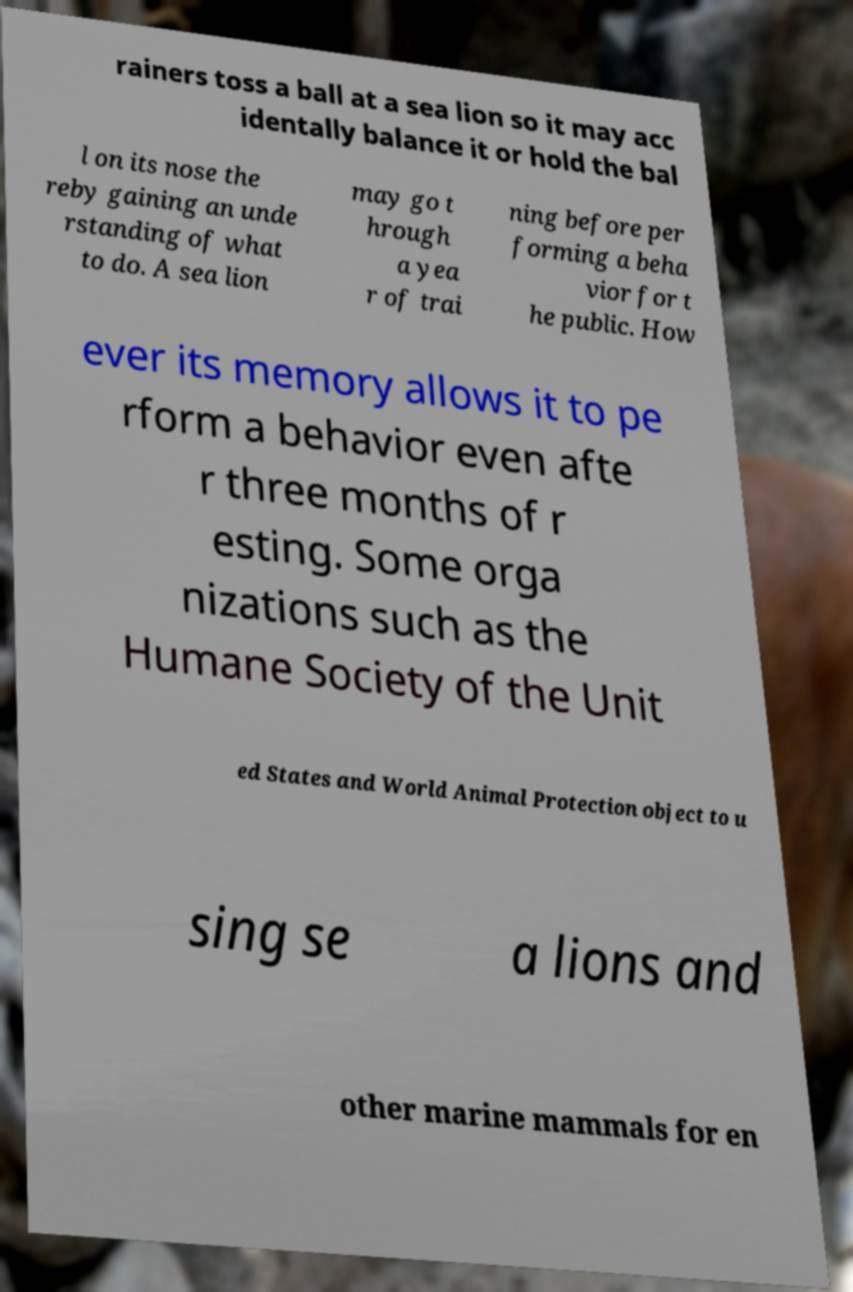Please identify and transcribe the text found in this image. rainers toss a ball at a sea lion so it may acc identally balance it or hold the bal l on its nose the reby gaining an unde rstanding of what to do. A sea lion may go t hrough a yea r of trai ning before per forming a beha vior for t he public. How ever its memory allows it to pe rform a behavior even afte r three months of r esting. Some orga nizations such as the Humane Society of the Unit ed States and World Animal Protection object to u sing se a lions and other marine mammals for en 